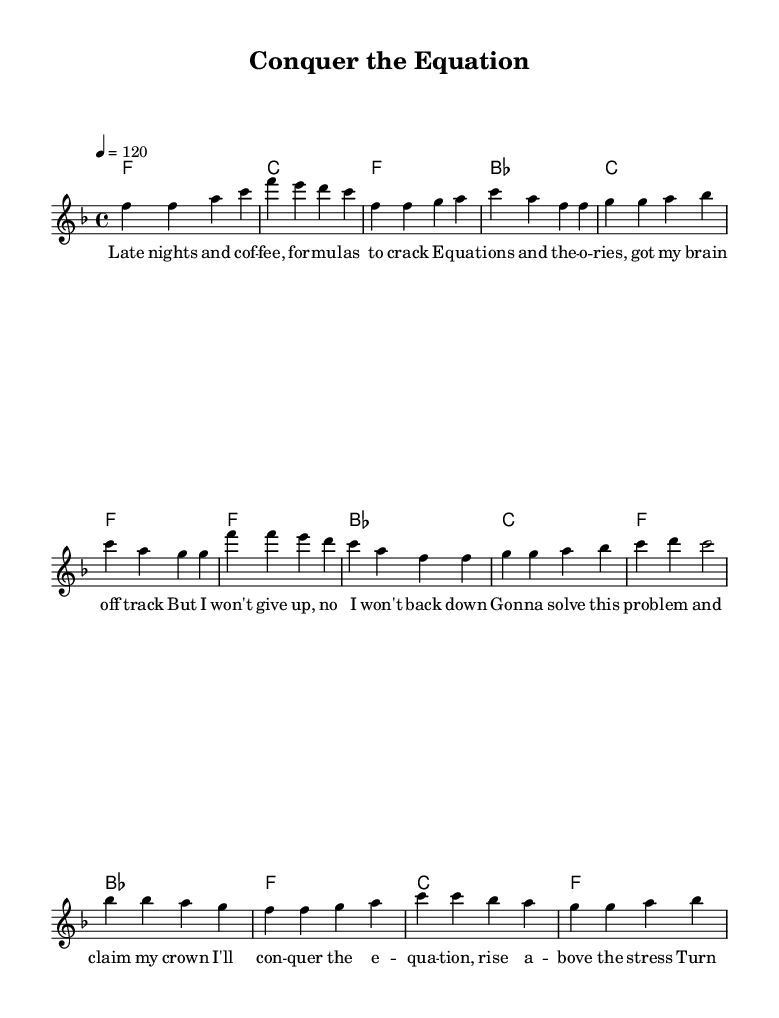What is the key signature of this music? The key signature is F major, which has one flat (B flat).
Answer: F major What is the time signature of the piece? The time signature is 4/4, indicating four beats per measure.
Answer: 4/4 What is the tempo marking for this piece? The tempo marking is 120 beats per minute, indicated by the symbol "4 = 120".
Answer: 120 How many measures are in the intro section? The intro consists of two measures, as indicated by the notation precedes the verse.
Answer: 2 What is the overall theme of the lyrics? The overall theme revolves around overcoming academic challenges and achieving success.
Answer: Overcoming academic challenges In which section of the song does the phrase "I'll conquer the equation" appear? This phrase appears in the chorus, which follows the verses.
Answer: Chorus How many different chords are played in the verse? Three different chords (F, B flat, and C) are played in the verse section.
Answer: 3 